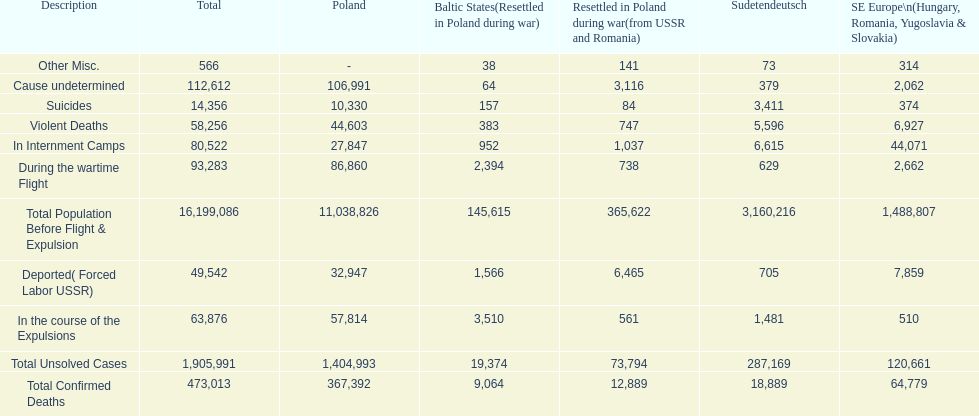Which region had the least total of unsolved cases? Baltic States(Resettled in Poland during war). 